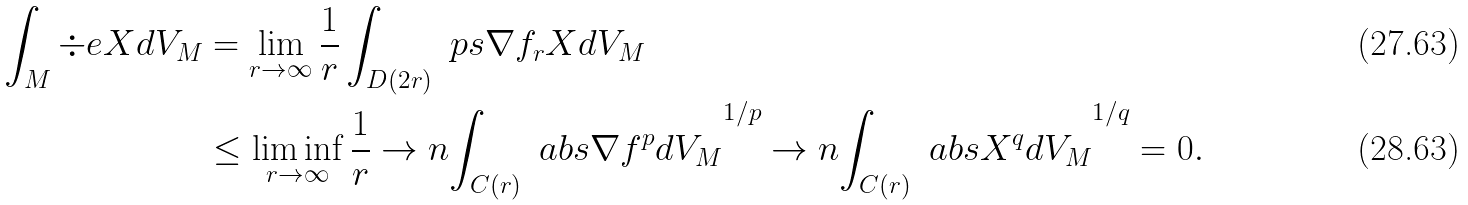<formula> <loc_0><loc_0><loc_500><loc_500>\int _ { M } \div e X d V _ { M } & = \lim _ { r \to \infty } \frac { 1 } { r } \int _ { D ( 2 r ) } \ p s { \nabla f _ { r } } { X } d V _ { M } \\ & \leq \liminf _ { r \to \infty } \frac { 1 } { r } \to n { \int _ { C ( r ) } \ a b s { \nabla f } ^ { p } d V _ { M } } ^ { 1 / p } \to n { \int _ { C ( r ) } \ a b s { X } ^ { q } d V _ { M } } ^ { 1 / q } = 0 .</formula> 